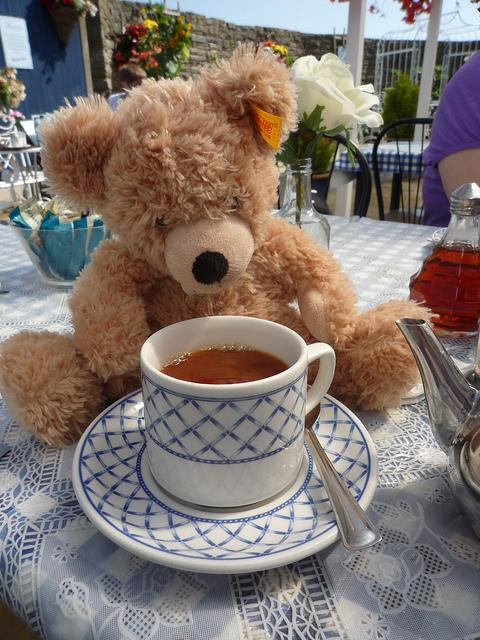Where does the teddy bear come from? Please explain your reasoning. america. The bear is from the usa. 